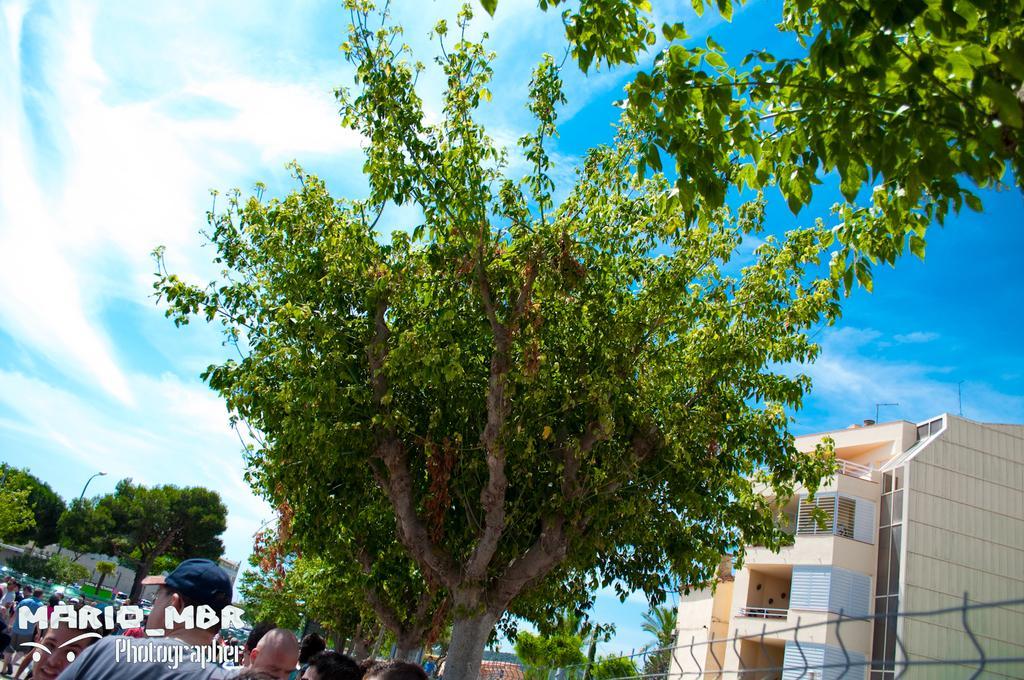Can you describe this image briefly? In the image, there is a tree and beside the tree there is a big building, on the left side there is a huge crowd standing beside a tree and in the background there is a pole light and around the pole light there are plenty of trees. 